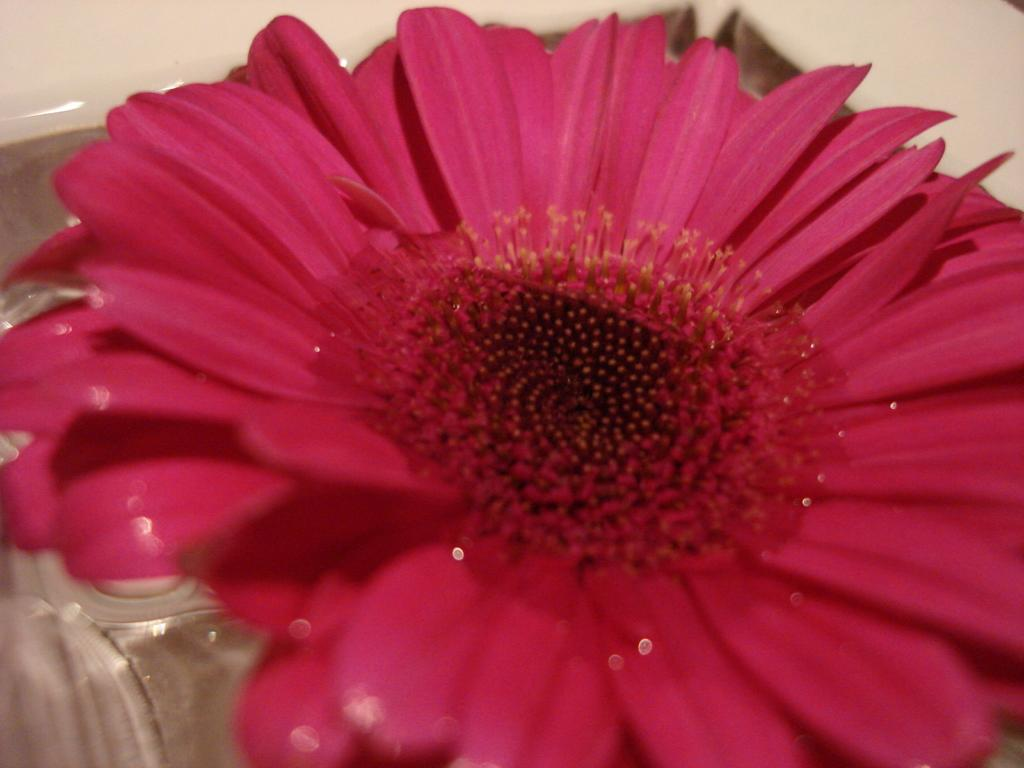What is the main subject in the foreground of the image? There is a sunflower in the foreground of the image. Can you describe the sunflower's environment in the image? The sunflower is in water. What type of toy can be seen floating in the water near the sunflower? There is no toy present in the image; it only features a sunflower in water. How many rings are visible around the sunflower in the image? There are no rings visible around the sunflower in the image. 